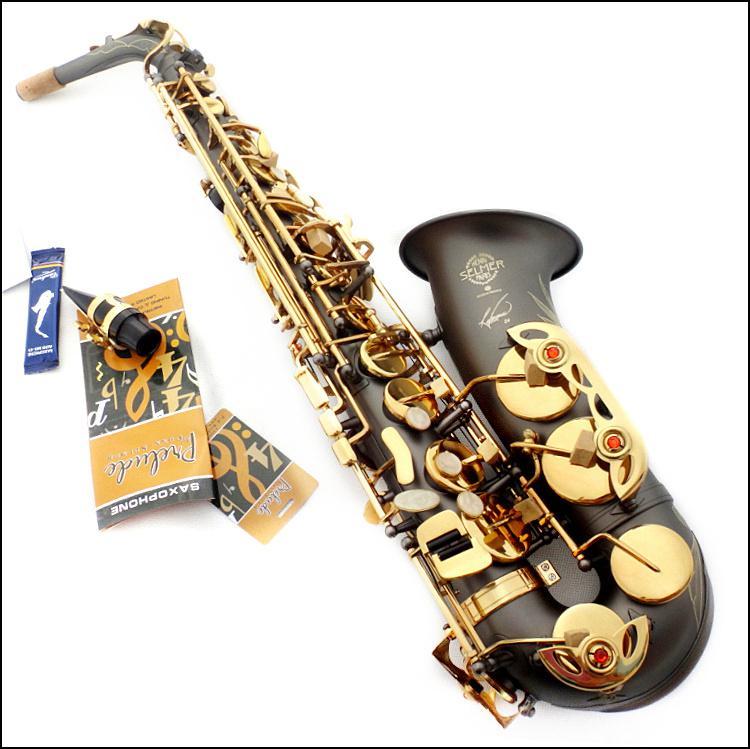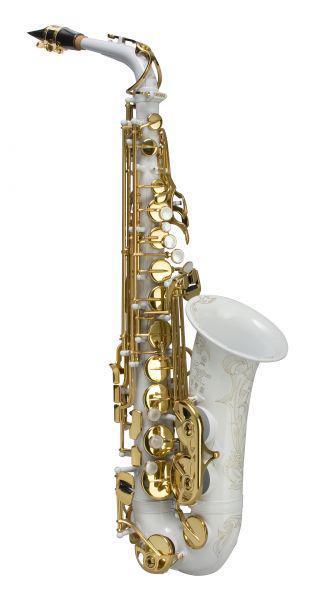The first image is the image on the left, the second image is the image on the right. Examine the images to the left and right. Is the description "The saxophone on the left is bright metallic blue with gold buttons and is posed with the bell facing rightward." accurate? Answer yes or no. No. The first image is the image on the left, the second image is the image on the right. For the images displayed, is the sentence "Each image has an instrument where the body is not gold, though all the buttons are." factually correct? Answer yes or no. Yes. 